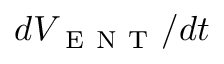Convert formula to latex. <formula><loc_0><loc_0><loc_500><loc_500>d V _ { E N T } / d t</formula> 